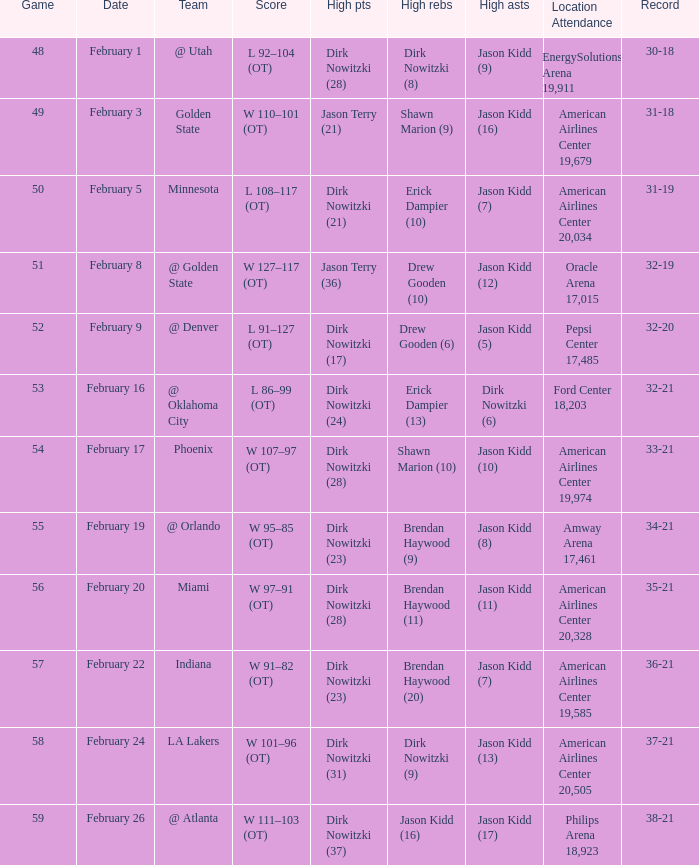When did the Mavericks have a record of 32-19? February 8. 